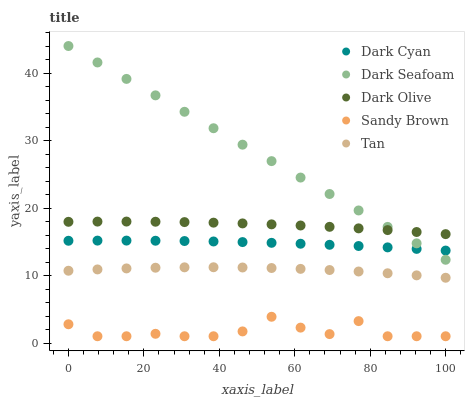Does Sandy Brown have the minimum area under the curve?
Answer yes or no. Yes. Does Dark Seafoam have the maximum area under the curve?
Answer yes or no. Yes. Does Dark Olive have the minimum area under the curve?
Answer yes or no. No. Does Dark Olive have the maximum area under the curve?
Answer yes or no. No. Is Dark Seafoam the smoothest?
Answer yes or no. Yes. Is Sandy Brown the roughest?
Answer yes or no. Yes. Is Dark Olive the smoothest?
Answer yes or no. No. Is Dark Olive the roughest?
Answer yes or no. No. Does Sandy Brown have the lowest value?
Answer yes or no. Yes. Does Dark Seafoam have the lowest value?
Answer yes or no. No. Does Dark Seafoam have the highest value?
Answer yes or no. Yes. Does Dark Olive have the highest value?
Answer yes or no. No. Is Tan less than Dark Olive?
Answer yes or no. Yes. Is Dark Cyan greater than Sandy Brown?
Answer yes or no. Yes. Does Dark Cyan intersect Dark Seafoam?
Answer yes or no. Yes. Is Dark Cyan less than Dark Seafoam?
Answer yes or no. No. Is Dark Cyan greater than Dark Seafoam?
Answer yes or no. No. Does Tan intersect Dark Olive?
Answer yes or no. No. 